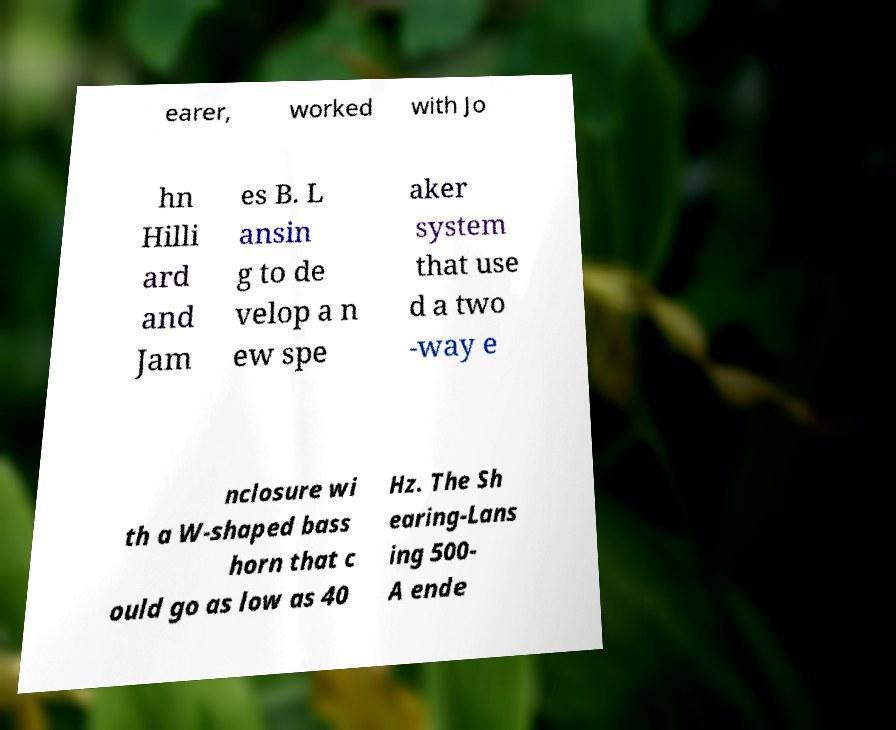For documentation purposes, I need the text within this image transcribed. Could you provide that? earer, worked with Jo hn Hilli ard and Jam es B. L ansin g to de velop a n ew spe aker system that use d a two -way e nclosure wi th a W-shaped bass horn that c ould go as low as 40 Hz. The Sh earing-Lans ing 500- A ende 